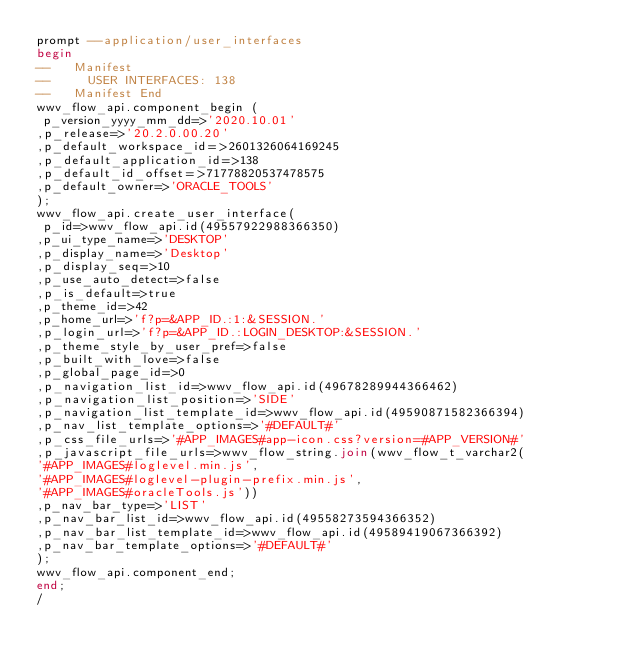<code> <loc_0><loc_0><loc_500><loc_500><_SQL_>prompt --application/user_interfaces
begin
--   Manifest
--     USER INTERFACES: 138
--   Manifest End
wwv_flow_api.component_begin (
 p_version_yyyy_mm_dd=>'2020.10.01'
,p_release=>'20.2.0.00.20'
,p_default_workspace_id=>2601326064169245
,p_default_application_id=>138
,p_default_id_offset=>71778820537478575
,p_default_owner=>'ORACLE_TOOLS'
);
wwv_flow_api.create_user_interface(
 p_id=>wwv_flow_api.id(49557922988366350)
,p_ui_type_name=>'DESKTOP'
,p_display_name=>'Desktop'
,p_display_seq=>10
,p_use_auto_detect=>false
,p_is_default=>true
,p_theme_id=>42
,p_home_url=>'f?p=&APP_ID.:1:&SESSION.'
,p_login_url=>'f?p=&APP_ID.:LOGIN_DESKTOP:&SESSION.'
,p_theme_style_by_user_pref=>false
,p_built_with_love=>false
,p_global_page_id=>0
,p_navigation_list_id=>wwv_flow_api.id(49678289944366462)
,p_navigation_list_position=>'SIDE'
,p_navigation_list_template_id=>wwv_flow_api.id(49590871582366394)
,p_nav_list_template_options=>'#DEFAULT#'
,p_css_file_urls=>'#APP_IMAGES#app-icon.css?version=#APP_VERSION#'
,p_javascript_file_urls=>wwv_flow_string.join(wwv_flow_t_varchar2(
'#APP_IMAGES#loglevel.min.js',
'#APP_IMAGES#loglevel-plugin-prefix.min.js',
'#APP_IMAGES#oracleTools.js'))
,p_nav_bar_type=>'LIST'
,p_nav_bar_list_id=>wwv_flow_api.id(49558273594366352)
,p_nav_bar_list_template_id=>wwv_flow_api.id(49589419067366392)
,p_nav_bar_template_options=>'#DEFAULT#'
);
wwv_flow_api.component_end;
end;
/
</code> 